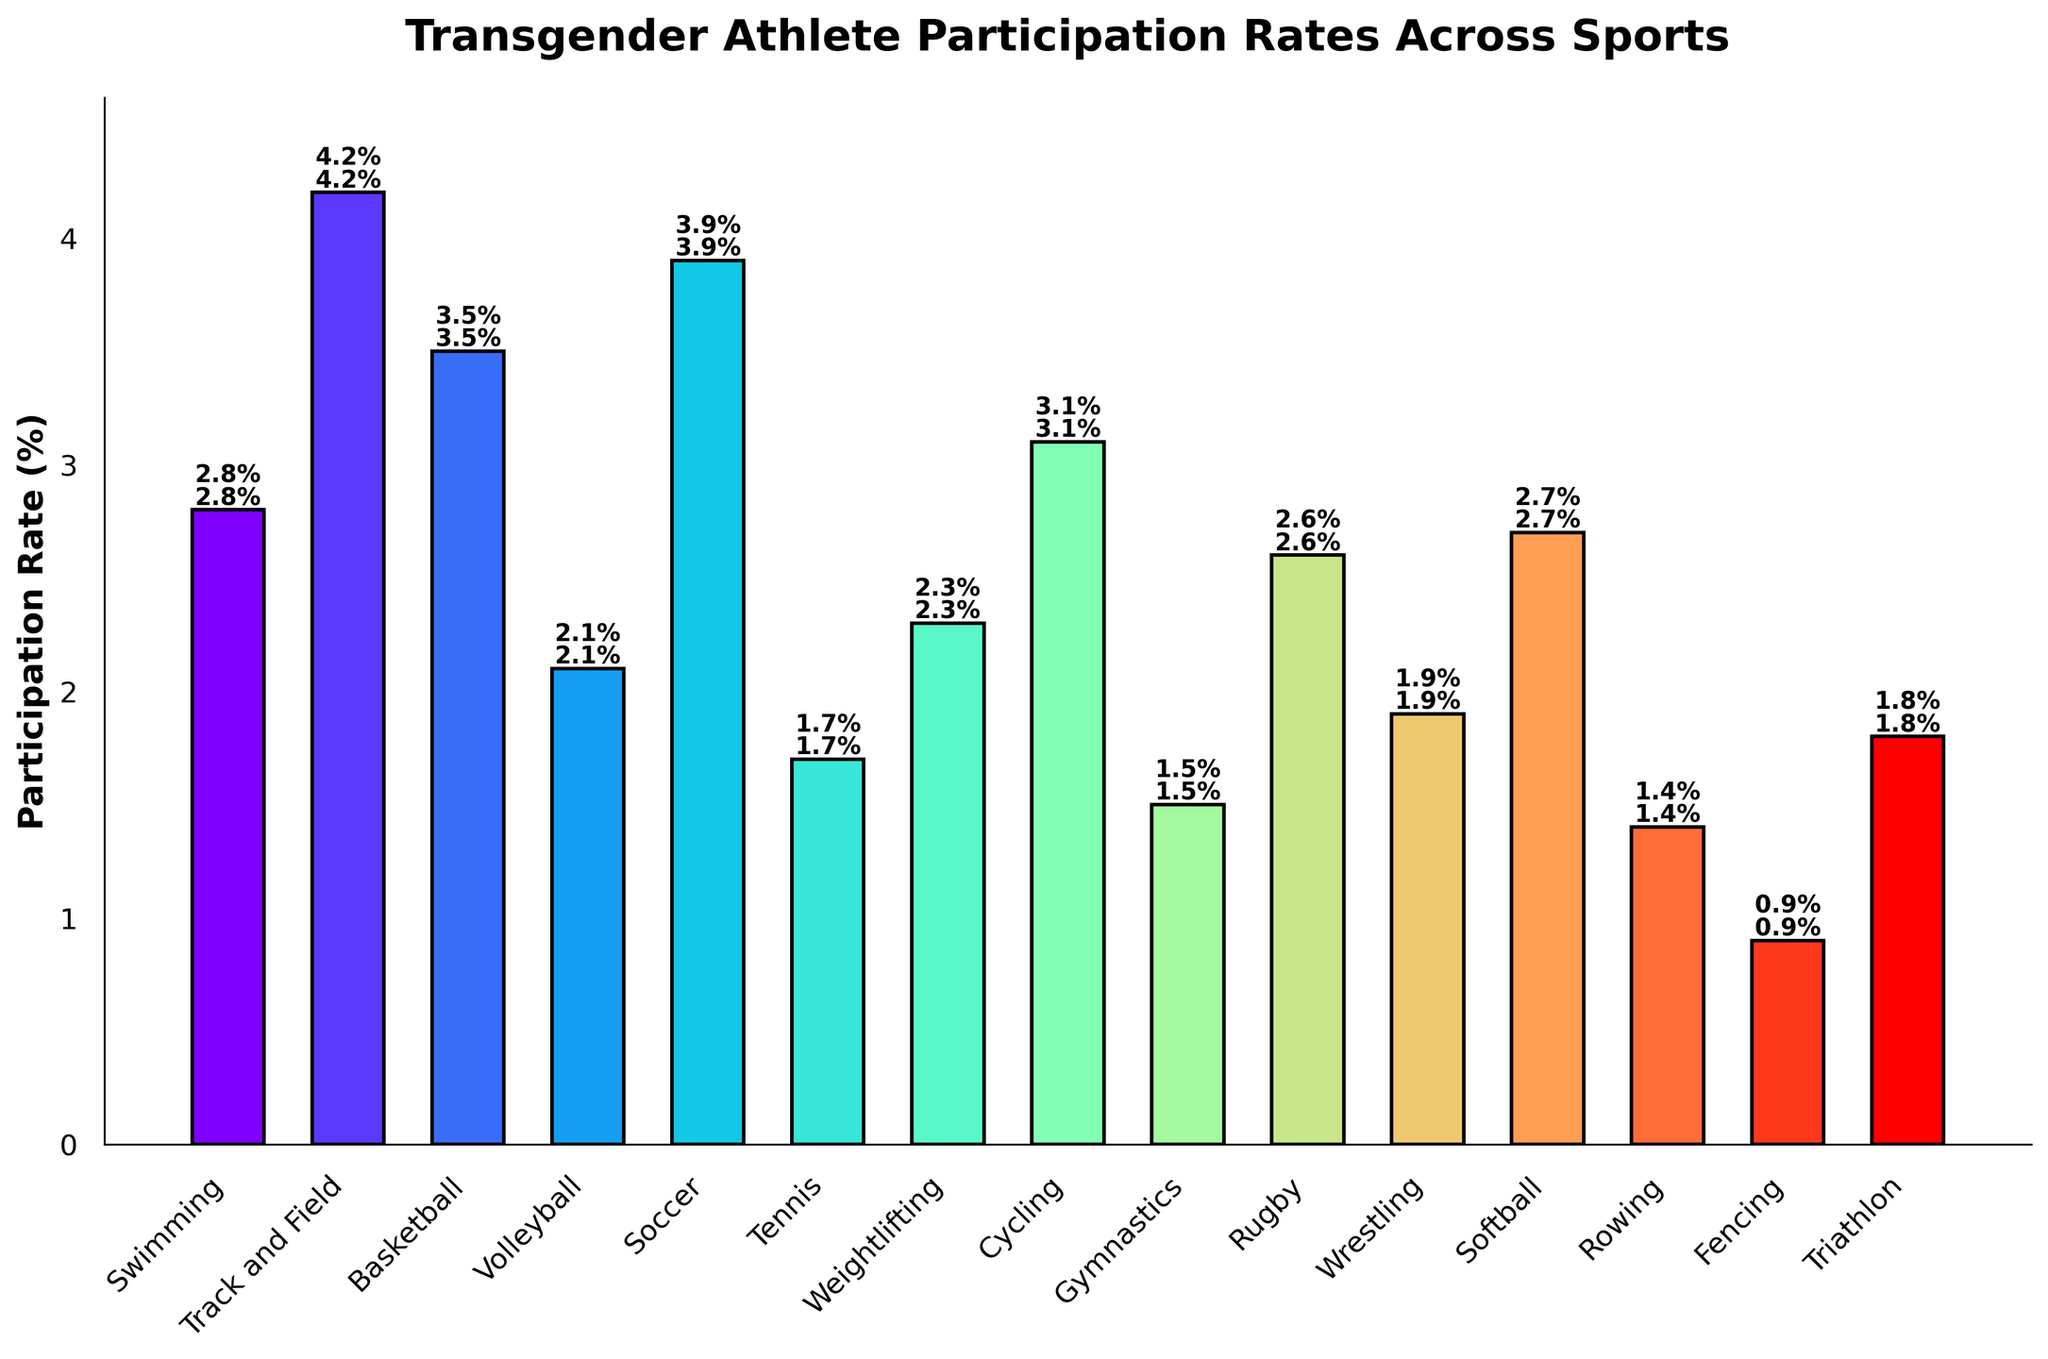Which sport has the highest participation rate of transgender athletes? By examining the bar chart, the height of the bar for Track and Field is the tallest, indicating the highest participation rate.
Answer: Track and Field What is the difference in participation rates between Soccer and Volleyball? The participation rate for Soccer is 3.9%, and for Volleyball, it is 2.1%. The difference is calculated by subtracting the smaller rate from the larger one: 3.9% - 2.1% = 1.8%.
Answer: 1.8% Which sport has the lowest participation rate of transgender athletes? The shortest bar in the chart represents Fencing, indicating the lowest participation rate.
Answer: Fencing Is the participation rate of transgender athletes higher in Cycling or Basketball? By comparing the heights of the bars for Cycling and Basketball, the bar for Basketball is taller, denoting a higher participation rate.
Answer: Basketball What is the combined participation rate of transgender athletes in Swimming, Wrestling, and Triathlon? The participation rates are 2.8% for Swimming, 1.9% for Wrestling, and 1.8% for Triathlon. Adding them together gives: 2.8% + 1.9% + 1.8% = 6.5%.
Answer: 6.5% Are there more sports with a participation rate above 2.5% or below 2.5%? Counting the bars above 2.5% (Swimming, Track and Field, Basketball, Soccer, Cycling, Softball, Rugby) and below 2.5% (Volleyball, Tennis, Weightlifting, Gymnastics, Wrestling, Rowing, Fencing, Triathlon), we find 7 sports above and 8 sports below.
Answer: Below 2.5% Between Rowing and Tennis, which sport has a lower participation rate of transgender athletes? Comparing the heights, Rowing has a shorter bar than Tennis, indicating a lower participation rate.
Answer: Rowing What is the average participation rate of transgender athletes across all sports? Summing all participation rates: 2.8 + 4.2 + 3.5 + 2.1 + 3.9 + 1.7 + 2.3 + 3.1 + 1.5 + 2.6 + 1.9 + 2.7 + 1.4 + 0.9 + 1.8 = 38.4. There are 15 sports, so the average is 38.4 / 15 ≈ 2.56%.
Answer: 2.56% Which sport has a participation rate closest to the overall average participation rate? The overall average participation rate is 2.56%. Softball has a rate of 2.7%, which is closest to this average.
Answer: Softball 